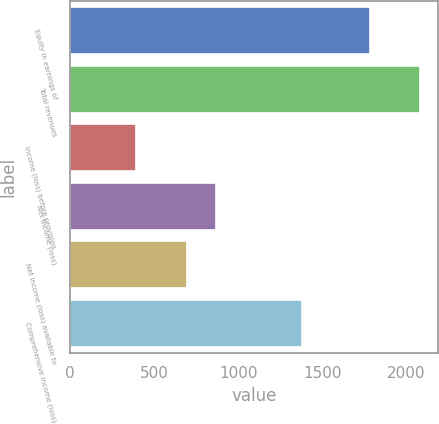Convert chart. <chart><loc_0><loc_0><loc_500><loc_500><bar_chart><fcel>Equity in earnings of<fcel>Total revenues<fcel>Income (loss) before provision<fcel>Net income (loss)<fcel>Net income (loss) available to<fcel>Comprehensive income (loss)<nl><fcel>1783<fcel>2081<fcel>392<fcel>865.9<fcel>697<fcel>1376<nl></chart> 